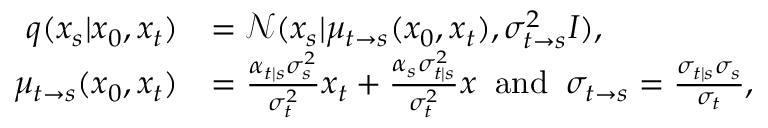<formula> <loc_0><loc_0><loc_500><loc_500>\begin{array} { r l } { q ( x _ { s } | x _ { 0 } , x _ { t } ) } & { = \mathcal { N } ( x _ { s } | \mu _ { t \rightarrow s } ( x _ { 0 } , x _ { t } ) , \sigma _ { t \rightarrow s } ^ { 2 } I ) , } \\ { \mu _ { t \rightarrow s } ( x _ { 0 } , x _ { t } ) } & { = \frac { \alpha _ { t | s } \sigma _ { s } ^ { 2 } } { \sigma _ { t } ^ { 2 } } x _ { t } + \frac { \alpha _ { s } \sigma _ { t | s } ^ { 2 } } { \sigma _ { t } ^ { 2 } } x \, a n d \, \sigma _ { t \rightarrow s } = \frac { \sigma _ { t | s } \sigma _ { s } } { \sigma _ { t } } , } \end{array}</formula> 